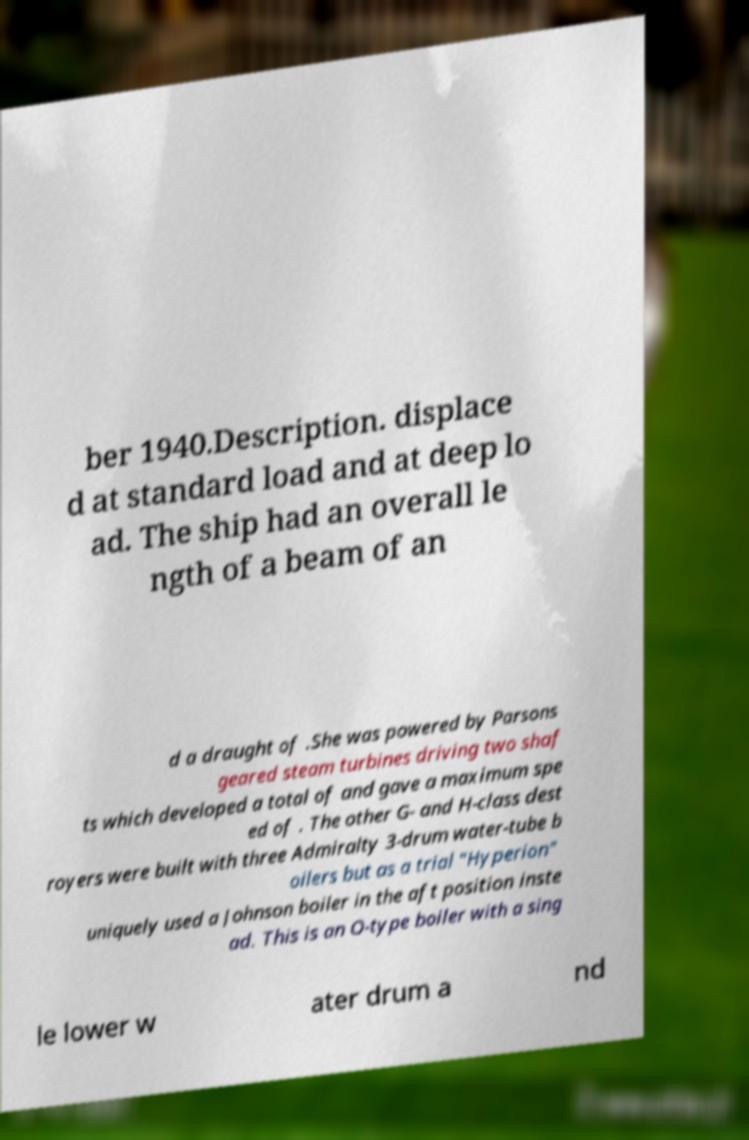There's text embedded in this image that I need extracted. Can you transcribe it verbatim? ber 1940.Description. displace d at standard load and at deep lo ad. The ship had an overall le ngth of a beam of an d a draught of .She was powered by Parsons geared steam turbines driving two shaf ts which developed a total of and gave a maximum spe ed of . The other G- and H-class dest royers were built with three Admiralty 3-drum water-tube b oilers but as a trial "Hyperion" uniquely used a Johnson boiler in the aft position inste ad. This is an O-type boiler with a sing le lower w ater drum a nd 